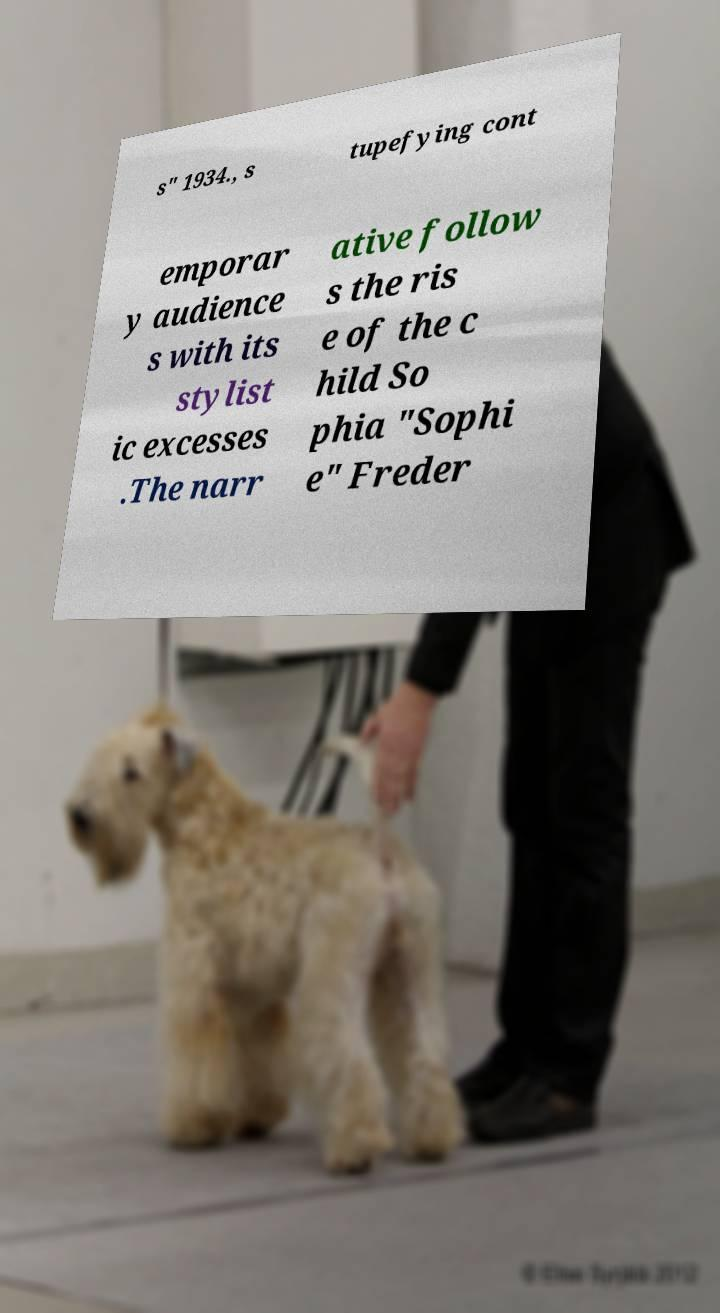Please read and relay the text visible in this image. What does it say? s" 1934., s tupefying cont emporar y audience s with its stylist ic excesses .The narr ative follow s the ris e of the c hild So phia "Sophi e" Freder 